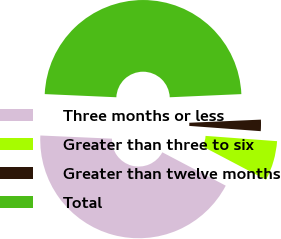<chart> <loc_0><loc_0><loc_500><loc_500><pie_chart><fcel>Three months or less<fcel>Greater than three to six<fcel>Greater than twelve months<fcel>Total<nl><fcel>42.99%<fcel>6.54%<fcel>1.87%<fcel>48.6%<nl></chart> 